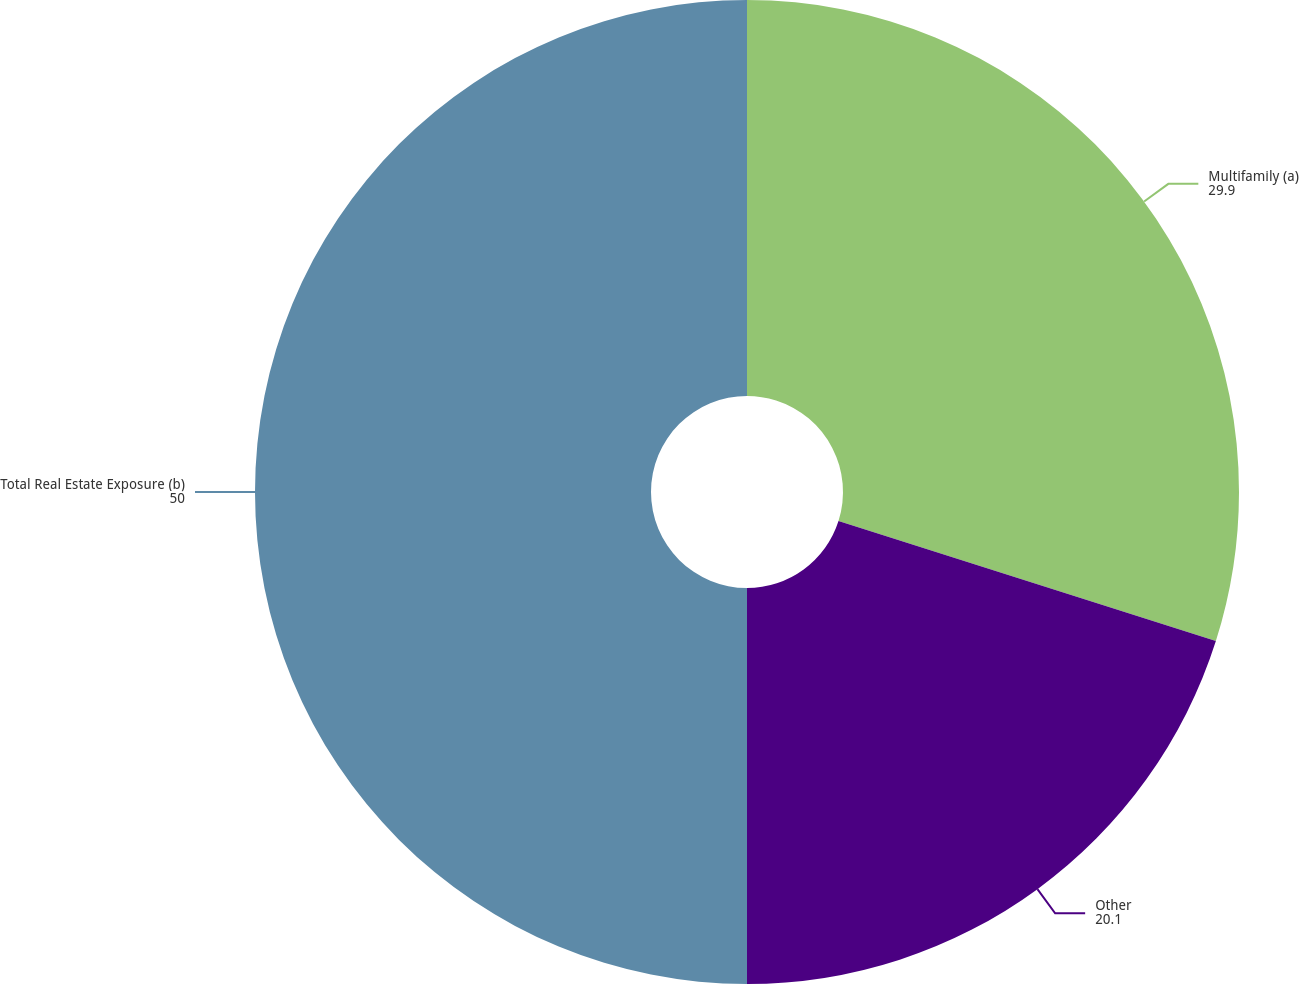Convert chart. <chart><loc_0><loc_0><loc_500><loc_500><pie_chart><fcel>Multifamily (a)<fcel>Other<fcel>Total Real Estate Exposure (b)<nl><fcel>29.9%<fcel>20.1%<fcel>50.0%<nl></chart> 